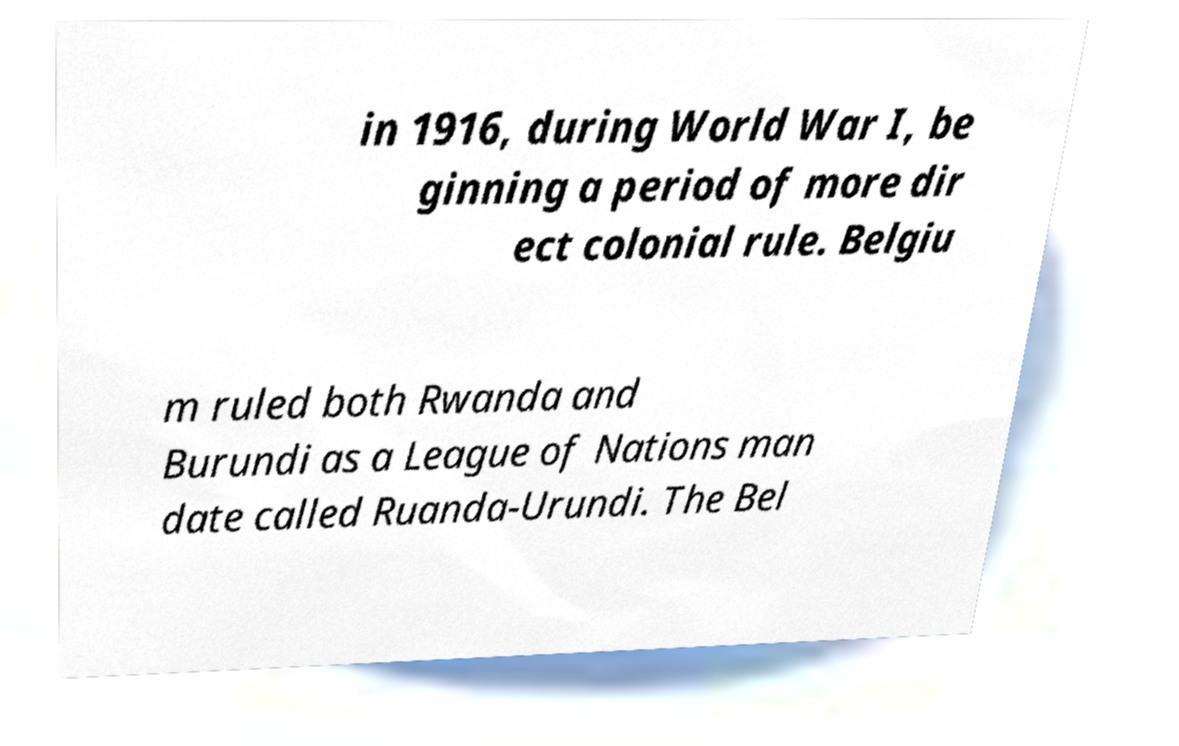What messages or text are displayed in this image? I need them in a readable, typed format. in 1916, during World War I, be ginning a period of more dir ect colonial rule. Belgiu m ruled both Rwanda and Burundi as a League of Nations man date called Ruanda-Urundi. The Bel 